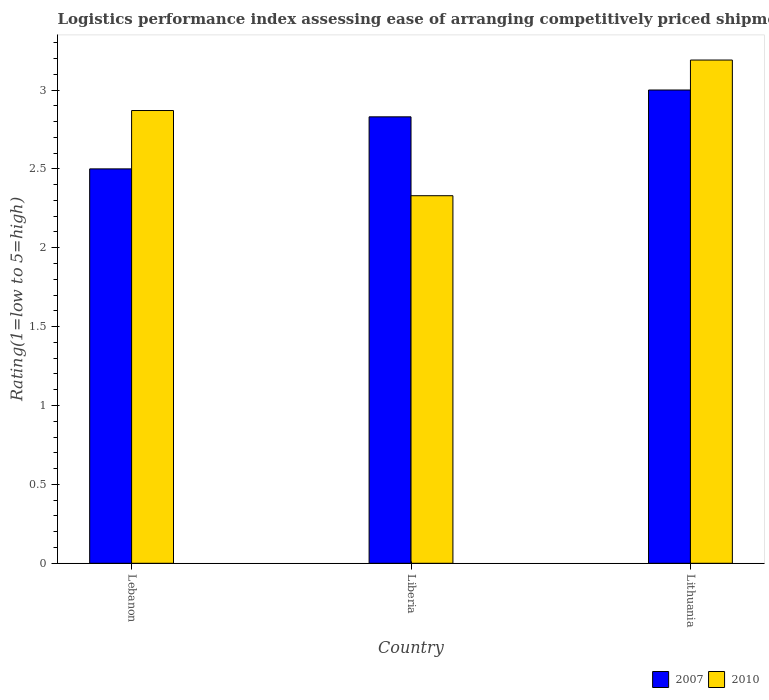How many groups of bars are there?
Ensure brevity in your answer.  3. What is the label of the 1st group of bars from the left?
Your answer should be very brief. Lebanon. In how many cases, is the number of bars for a given country not equal to the number of legend labels?
Offer a very short reply. 0. What is the Logistic performance index in 2007 in Lebanon?
Provide a succinct answer. 2.5. Across all countries, what is the maximum Logistic performance index in 2007?
Ensure brevity in your answer.  3. In which country was the Logistic performance index in 2007 maximum?
Keep it short and to the point. Lithuania. In which country was the Logistic performance index in 2010 minimum?
Make the answer very short. Liberia. What is the total Logistic performance index in 2007 in the graph?
Your response must be concise. 8.33. What is the difference between the Logistic performance index in 2010 in Lebanon and the Logistic performance index in 2007 in Liberia?
Provide a succinct answer. 0.04. What is the average Logistic performance index in 2007 per country?
Provide a succinct answer. 2.78. What is the difference between the Logistic performance index of/in 2007 and Logistic performance index of/in 2010 in Lebanon?
Give a very brief answer. -0.37. What is the ratio of the Logistic performance index in 2007 in Liberia to that in Lithuania?
Your answer should be compact. 0.94. What is the difference between the highest and the second highest Logistic performance index in 2007?
Offer a terse response. -0.33. What is the difference between the highest and the lowest Logistic performance index in 2007?
Your response must be concise. 0.5. Is the sum of the Logistic performance index in 2010 in Lebanon and Lithuania greater than the maximum Logistic performance index in 2007 across all countries?
Offer a very short reply. Yes. What does the 1st bar from the left in Lebanon represents?
Your answer should be very brief. 2007. How many bars are there?
Make the answer very short. 6. Are all the bars in the graph horizontal?
Offer a very short reply. No. How many countries are there in the graph?
Give a very brief answer. 3. What is the difference between two consecutive major ticks on the Y-axis?
Give a very brief answer. 0.5. Are the values on the major ticks of Y-axis written in scientific E-notation?
Offer a terse response. No. Does the graph contain grids?
Offer a very short reply. No. Where does the legend appear in the graph?
Give a very brief answer. Bottom right. How many legend labels are there?
Your answer should be very brief. 2. What is the title of the graph?
Your response must be concise. Logistics performance index assessing ease of arranging competitively priced shipments to markets. Does "1960" appear as one of the legend labels in the graph?
Offer a very short reply. No. What is the label or title of the X-axis?
Provide a succinct answer. Country. What is the label or title of the Y-axis?
Ensure brevity in your answer.  Rating(1=low to 5=high). What is the Rating(1=low to 5=high) in 2007 in Lebanon?
Ensure brevity in your answer.  2.5. What is the Rating(1=low to 5=high) in 2010 in Lebanon?
Provide a short and direct response. 2.87. What is the Rating(1=low to 5=high) in 2007 in Liberia?
Keep it short and to the point. 2.83. What is the Rating(1=low to 5=high) in 2010 in Liberia?
Your answer should be compact. 2.33. What is the Rating(1=low to 5=high) of 2007 in Lithuania?
Offer a terse response. 3. What is the Rating(1=low to 5=high) in 2010 in Lithuania?
Your answer should be compact. 3.19. Across all countries, what is the maximum Rating(1=low to 5=high) in 2010?
Give a very brief answer. 3.19. Across all countries, what is the minimum Rating(1=low to 5=high) in 2010?
Offer a very short reply. 2.33. What is the total Rating(1=low to 5=high) in 2007 in the graph?
Make the answer very short. 8.33. What is the total Rating(1=low to 5=high) in 2010 in the graph?
Make the answer very short. 8.39. What is the difference between the Rating(1=low to 5=high) of 2007 in Lebanon and that in Liberia?
Your answer should be compact. -0.33. What is the difference between the Rating(1=low to 5=high) in 2010 in Lebanon and that in Liberia?
Ensure brevity in your answer.  0.54. What is the difference between the Rating(1=low to 5=high) in 2010 in Lebanon and that in Lithuania?
Offer a terse response. -0.32. What is the difference between the Rating(1=low to 5=high) of 2007 in Liberia and that in Lithuania?
Keep it short and to the point. -0.17. What is the difference between the Rating(1=low to 5=high) of 2010 in Liberia and that in Lithuania?
Your answer should be compact. -0.86. What is the difference between the Rating(1=low to 5=high) in 2007 in Lebanon and the Rating(1=low to 5=high) in 2010 in Liberia?
Make the answer very short. 0.17. What is the difference between the Rating(1=low to 5=high) of 2007 in Lebanon and the Rating(1=low to 5=high) of 2010 in Lithuania?
Offer a terse response. -0.69. What is the difference between the Rating(1=low to 5=high) in 2007 in Liberia and the Rating(1=low to 5=high) in 2010 in Lithuania?
Provide a short and direct response. -0.36. What is the average Rating(1=low to 5=high) of 2007 per country?
Keep it short and to the point. 2.78. What is the average Rating(1=low to 5=high) in 2010 per country?
Your answer should be compact. 2.8. What is the difference between the Rating(1=low to 5=high) in 2007 and Rating(1=low to 5=high) in 2010 in Lebanon?
Make the answer very short. -0.37. What is the difference between the Rating(1=low to 5=high) in 2007 and Rating(1=low to 5=high) in 2010 in Liberia?
Ensure brevity in your answer.  0.5. What is the difference between the Rating(1=low to 5=high) of 2007 and Rating(1=low to 5=high) of 2010 in Lithuania?
Provide a short and direct response. -0.19. What is the ratio of the Rating(1=low to 5=high) of 2007 in Lebanon to that in Liberia?
Make the answer very short. 0.88. What is the ratio of the Rating(1=low to 5=high) in 2010 in Lebanon to that in Liberia?
Provide a succinct answer. 1.23. What is the ratio of the Rating(1=low to 5=high) in 2010 in Lebanon to that in Lithuania?
Keep it short and to the point. 0.9. What is the ratio of the Rating(1=low to 5=high) of 2007 in Liberia to that in Lithuania?
Offer a very short reply. 0.94. What is the ratio of the Rating(1=low to 5=high) of 2010 in Liberia to that in Lithuania?
Make the answer very short. 0.73. What is the difference between the highest and the second highest Rating(1=low to 5=high) in 2007?
Offer a terse response. 0.17. What is the difference between the highest and the second highest Rating(1=low to 5=high) in 2010?
Your answer should be very brief. 0.32. What is the difference between the highest and the lowest Rating(1=low to 5=high) of 2007?
Provide a succinct answer. 0.5. What is the difference between the highest and the lowest Rating(1=low to 5=high) of 2010?
Ensure brevity in your answer.  0.86. 